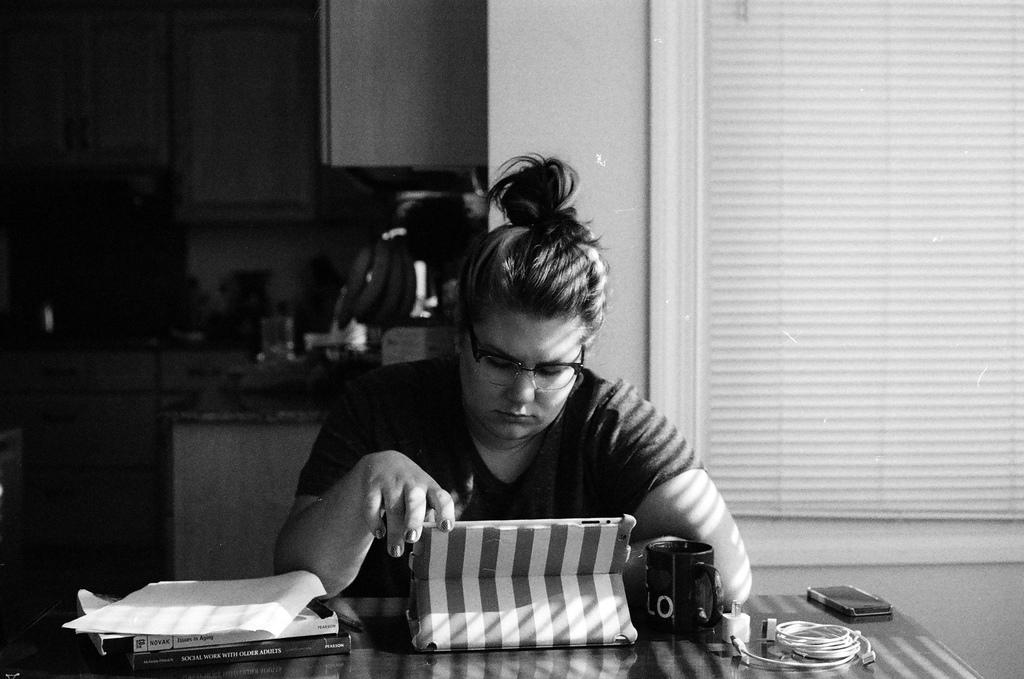Who is present in the image? There is a woman in the image. What objects are on the table in the image? There are books, paper, a box, a cup, a charger, and a phone on the table. Can you describe the table setting in the image? The table has various objects on it, including books, paper, a box, a cup, a charger, and a phone. What can be seen in the background of the image? There are objects visible in the background, including a wooden cupboard. How much money is the woman holding in the image? There is no money visible in the image. Are there any geese present in the image? No, there are no geese present in the image. 